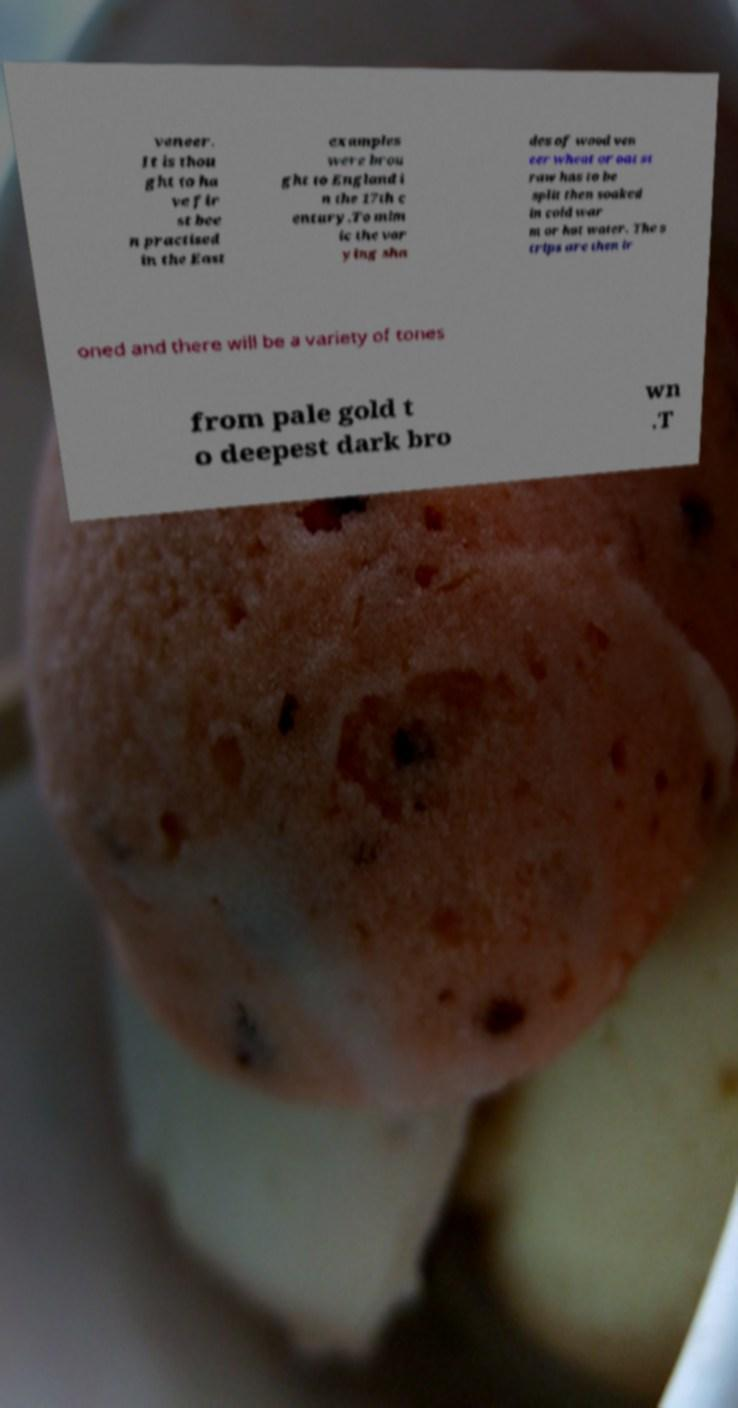Can you read and provide the text displayed in the image?This photo seems to have some interesting text. Can you extract and type it out for me? veneer. It is thou ght to ha ve fir st bee n practised in the East examples were brou ght to England i n the 17th c entury.To mim ic the var ying sha des of wood ven eer wheat or oat st raw has to be split then soaked in cold war m or hot water. The s trips are then ir oned and there will be a variety of tones from pale gold t o deepest dark bro wn .T 